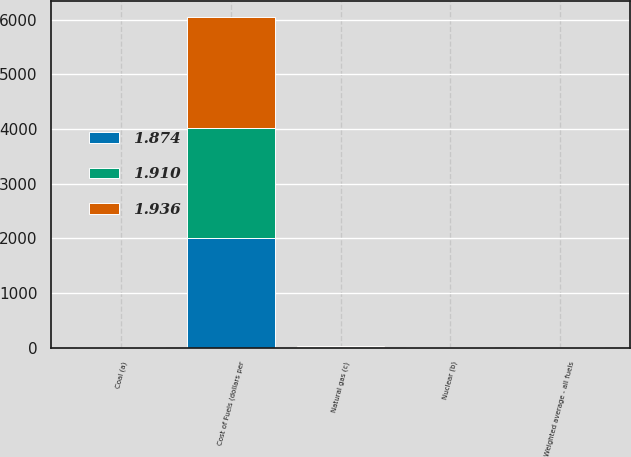Convert chart. <chart><loc_0><loc_0><loc_500><loc_500><stacked_bar_chart><ecel><fcel>Cost of Fuels (dollars per<fcel>Coal (a)<fcel>Nuclear (b)<fcel>Natural gas (c)<fcel>Weighted average - all fuels<nl><fcel>1.936<fcel>2015<fcel>2.19<fcel>0.93<fcel>7.42<fcel>1.91<nl><fcel>1.91<fcel>2014<fcel>2.15<fcel>0.92<fcel>11.23<fcel>1.94<nl><fcel>1.874<fcel>2013<fcel>2.05<fcel>0.94<fcel>7.91<fcel>1.87<nl></chart> 